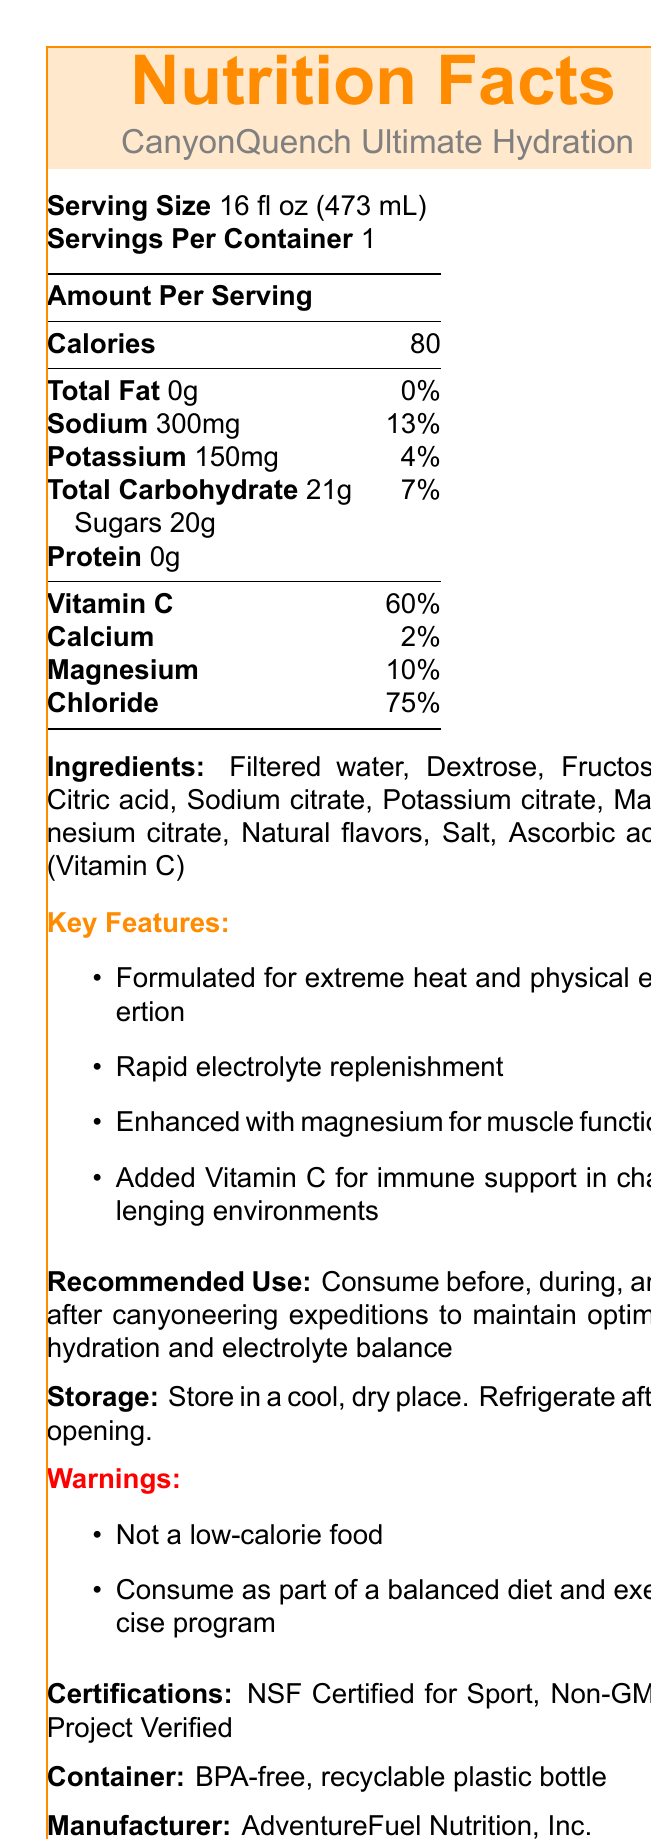what is the serving size of CanyonQuench Ultimate Hydration? The serving size is clearly listed as "16 fl oz (473 mL)" in the document.
Answer: 16 fl oz (473 mL) how many calories are in one serving? The document lists the amount of calories per serving as 80.
Answer: 80 which electrolytes are included in CanyonQuench Ultimate Hydration? The document lists electrolytes in the "Amount Per Serving" section: Sodium (300mg), Potassium (150mg), Magnesium (10%), Chloride (75%).
Answer: Sodium, Potassium, Magnesium, Chloride what is the percentage of daily value for Vitamin C per serving? The document lists Vitamin C with a daily value percentage of 60%.
Answer: 60% what are the key ingredients in this sports drink? The ingredients are listed under the "Ingredients" section of the document.
Answer: Filtered water, Dextrose, Fructose, Citric acid, Sodium citrate, Potassium citrate, Magnesium citrate, Natural flavors, Salt, Ascorbic acid (Vitamin C) which of the following is NOT listed as a key feature of CanyonQuench Ultimate Hydration? A. Formulated for cold climates B. Rapid electrolyte replenishment C. Enhanced with magnesium for muscle function D. Added Vitamin C for immune support The document lists key features mentioning extreme heat and physical exertion, rapid electrolyte replenishment, enhanced with magnesium, and added Vitamin C, but nothing about cold climates.
Answer: A how should I store CanyonQuench Ultimate Hydration after opening? The document provides storage instructions stating to refrigerate after opening.
Answer: Refrigerate after opening true or false: CanyonQuench Ultimate Hydration is NSF Certified for Sport. The certifications section lists NSF Certified for Sport.
Answer: True describe the main purpose of CanyonQuench Ultimate Hydration according to the document. The document describes this sports drink as being specially formulated for challenging conditions to help maintain hydration and provide essential nutrients and electrolytes.
Answer: CanyonQuench Ultimate Hydration is formulated for extreme heat and physical exertion, providing rapid electrolyte replenishment, and is enhanced with magnesium for muscle function and Vitamin C for immune support. It is recommended for use before, during, and after canyoneering expeditions to maintain optimal hydration and electrolyte balance. what is the caloric content of CanyonQuench Ultimate Hydration? This cannot be determined solely from the provided document as it requires additional context or information about all ingredients' caloric content.
Answer: Cannot be determined 